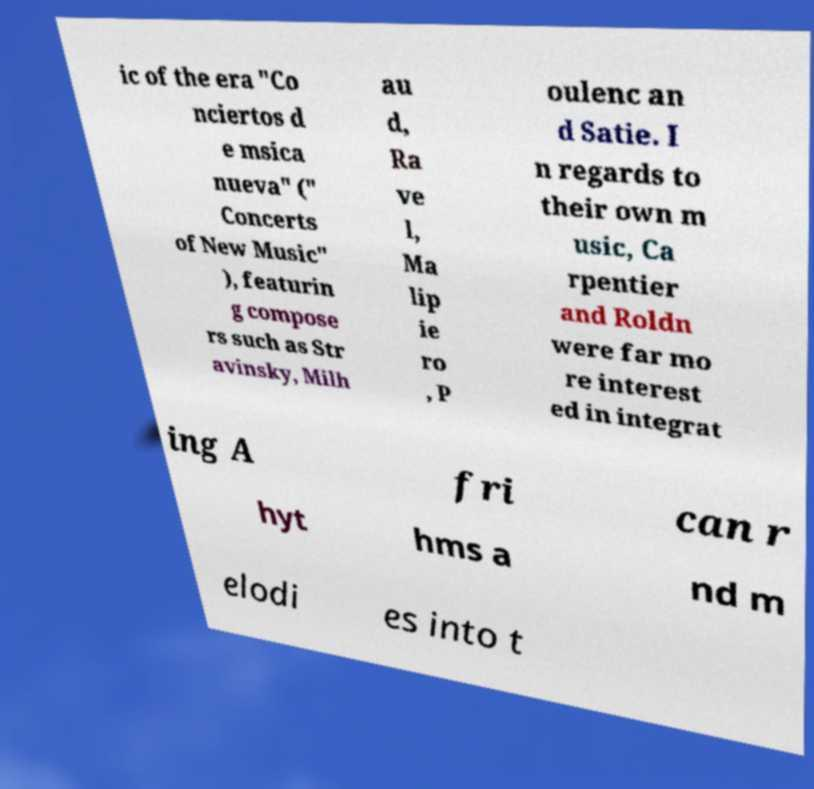I need the written content from this picture converted into text. Can you do that? ic of the era "Co nciertos d e msica nueva" (" Concerts of New Music" ), featurin g compose rs such as Str avinsky, Milh au d, Ra ve l, Ma lip ie ro , P oulenc an d Satie. I n regards to their own m usic, Ca rpentier and Roldn were far mo re interest ed in integrat ing A fri can r hyt hms a nd m elodi es into t 